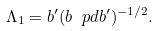Convert formula to latex. <formula><loc_0><loc_0><loc_500><loc_500>\Lambda _ { 1 } = b ^ { \prime } ( b \ p d b ^ { \prime } ) ^ { - 1 / 2 } .</formula> 